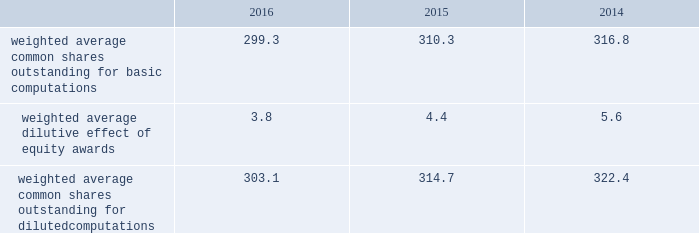Benefits as an increase to earnings of $ 152 million ( $ 0.50 per share ) during the year ended december 31 , 2016 .
Additionally , we recognized additional income tax benefits as an increase to operating cash flows of $ 152 million during the year ended december 31 , 2016 .
The new accounting standard did not impact any periods prior to january 1 , 2016 , as we applied the changes in the asu on a prospective basis .
In september 2015 , the fasb issued asu no .
2015-16 , business combinations ( topic 805 ) , which simplifies the accounting for adjustments made to preliminary amounts recognized in a business combination by eliminating the requirement to retrospectively account for those adjustments .
Instead , adjustments will be recognized in the period in which the adjustments are determined , including the effect on earnings of any amounts that would have been recorded in previous periods if the accounting had been completed at the acquisition date .
We adopted the asu on january 1 , 2016 and are prospectively applying the asu to business combination adjustments identified after the date of adoption .
In november 2015 , the fasb issued asu no .
2015-17 , income taxes ( topic 740 ) , which simplifies the presentation of deferred income taxes and requires that deferred tax assets and liabilities , as well as any related valuation allowance , be classified as noncurrent in our consolidated balance sheets .
We applied the provisions of the asu retrospectively and reclassified approximately $ 1.6 billion from current to noncurrent assets and approximately $ 140 million from current to noncurrent liabilities in our consolidated balance sheet as of december 31 , 2015 .
Note 2 2013 earnings per share the weighted average number of shares outstanding used to compute earnings per common share were as follows ( in millions ) : .
We compute basic and diluted earnings per common share by dividing net earnings by the respective weighted average number of common shares outstanding for the periods presented .
Our calculation of diluted earnings per common share also includes the dilutive effects for the assumed vesting of outstanding restricted stock units and exercise of outstanding stock options based on the treasury stock method .
There were no anti-dilutive equity awards for the years ended december 31 , 2016 , 2015 and 2014 .
Note 3 2013 acquisitions and divestitures acquisitions acquisition of sikorsky aircraft corporation on november 6 , 2015 , we completed the acquisition of sikorsky aircraft corporation and certain affiliated companies ( collectively 201csikorsky 201d ) from united technologies corporation ( utc ) and certain of utc 2019s subsidiaries .
The purchase price of the acquisition was $ 9.0 billion , net of cash acquired .
As a result of the acquisition , sikorsky became a wholly- owned subsidiary of ours .
Sikorsky is a global company primarily engaged in the research , design , development , manufacture and support of military and commercial helicopters .
Sikorsky 2019s products include military helicopters such as the black hawk , seahawk , ch-53k , h-92 ; and commercial helicopters such as the s-76 and s-92 .
The acquisition enables us to extend our core business into the military and commercial rotary wing markets , allowing us to strengthen our position in the aerospace and defense industry .
Further , this acquisition will expand our presence in commercial and international markets .
Sikorsky has been aligned under our rms business segment .
To fund the $ 9.0 billion acquisition price , we utilized $ 6.0 billion of proceeds borrowed under a temporary 364-day revolving credit facility ( the 364-day facility ) , $ 2.0 billion of cash on hand and $ 1.0 billion from the issuance of commercial paper .
In the fourth quarter of 2015 , we repaid all outstanding borrowings under the 364-day facility with the proceeds from the issuance of $ 7.0 billion of fixed interest-rate long-term notes in a public offering ( the november 2015 notes ) .
In the fourth quarter of 2015 , we also repaid the $ 1.0 billion in commercial paper borrowings ( see 201cnote 10 2013 debt 201d ) . .
What is the percentage change in weighted average common shares outstanding for basic computations from 2015 to 2016? 
Rationale: what is the percentage change in weighted average common shares outstanding for basic computations from 2015 to 2016?
Computations: ((299.3 - 310.3) / 310.3)
Answer: -0.03545. 